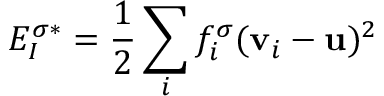<formula> <loc_0><loc_0><loc_500><loc_500>E _ { I } ^ { \sigma * } = \frac { 1 } { 2 } \sum _ { i } f _ { i } ^ { \sigma } ( v _ { i } - u ) ^ { 2 }</formula> 